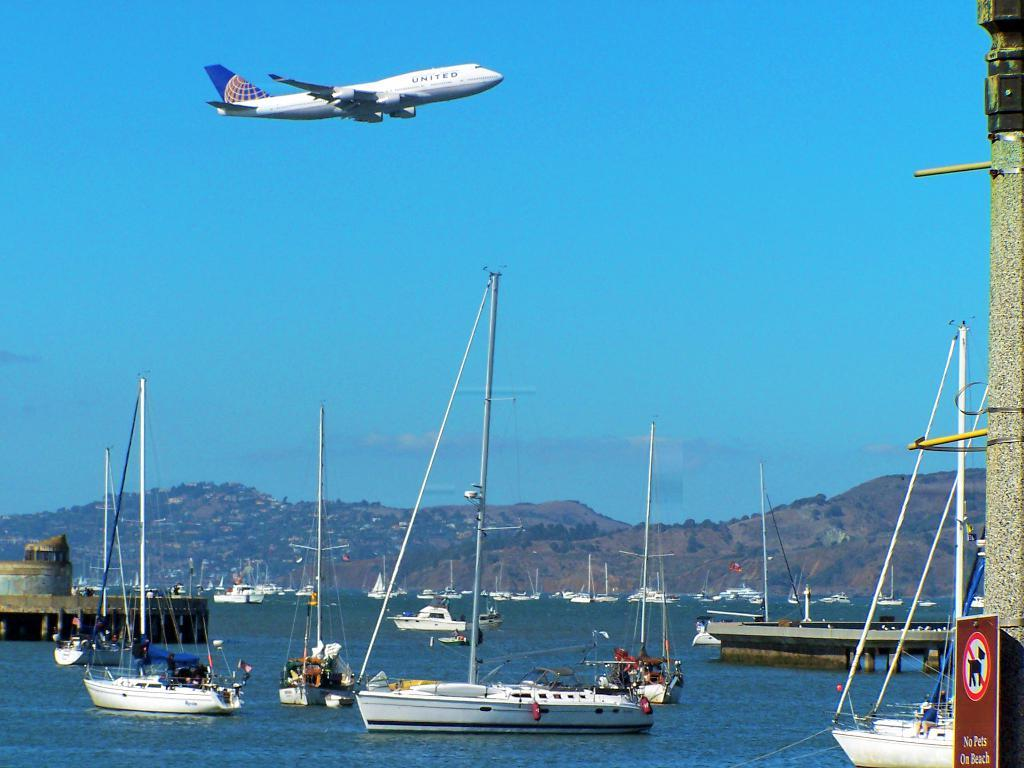What is on the water in the image? There are boats on the water in the image. What can be seen in the distance in the image? Mountains and trees with green color are visible in the background of the image. What type of vehicle is in the image? There is an aircraft in white color in the image. What is the color of the sky in the image? The sky is blue in the image. Can you see any fingers in the image? There are no fingers visible in the image. Is there a garden in the image? There is no garden present in the image. 